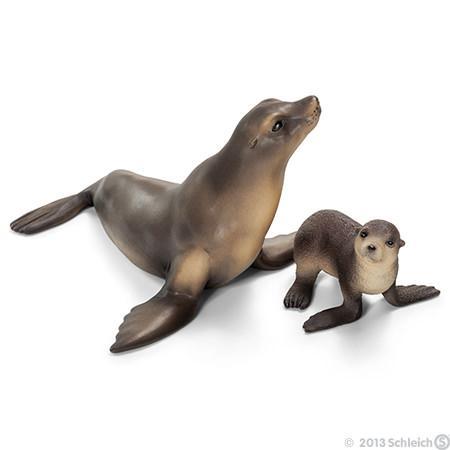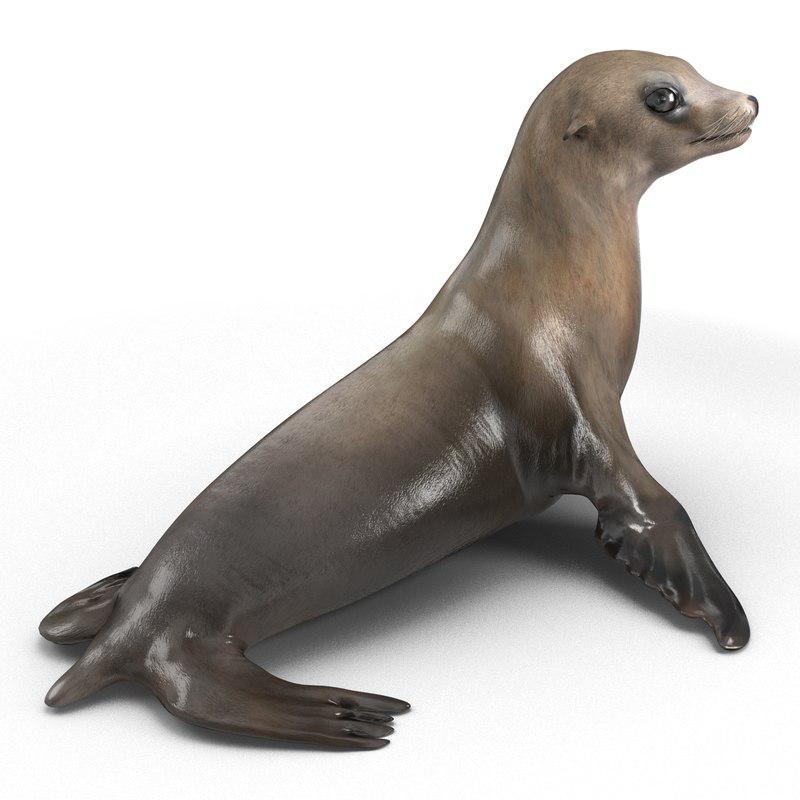The first image is the image on the left, the second image is the image on the right. Given the left and right images, does the statement "1 seal is pointed toward the right outside." hold true? Answer yes or no. No. 